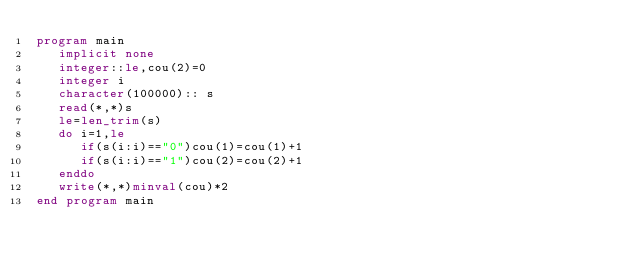Convert code to text. <code><loc_0><loc_0><loc_500><loc_500><_FORTRAN_>program main
   implicit none
   integer::le,cou(2)=0
   integer i
   character(100000):: s
   read(*,*)s
   le=len_trim(s)
   do i=1,le
      if(s(i:i)=="0")cou(1)=cou(1)+1
      if(s(i:i)=="1")cou(2)=cou(2)+1
   enddo
   write(*,*)minval(cou)*2
end program main
</code> 